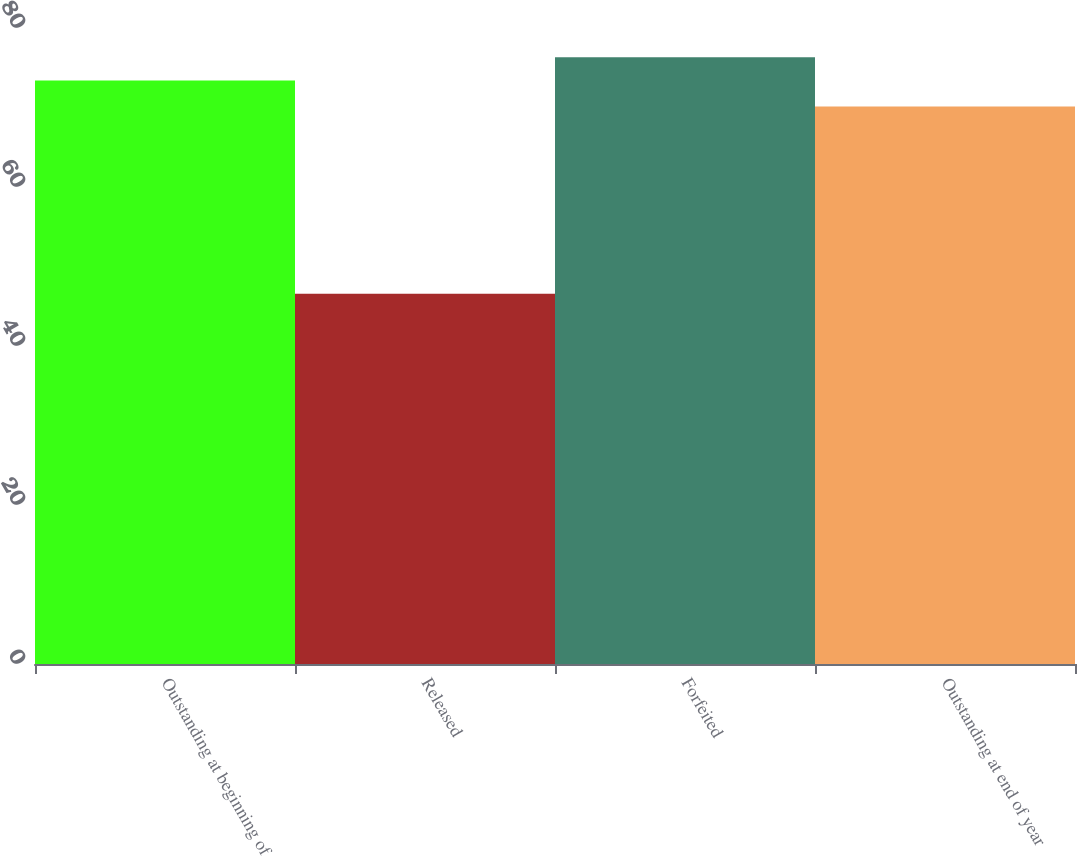Convert chart. <chart><loc_0><loc_0><loc_500><loc_500><bar_chart><fcel>Outstanding at beginning of<fcel>Released<fcel>Forfeited<fcel>Outstanding at end of year<nl><fcel>73.4<fcel>46.58<fcel>76.32<fcel>70.14<nl></chart> 